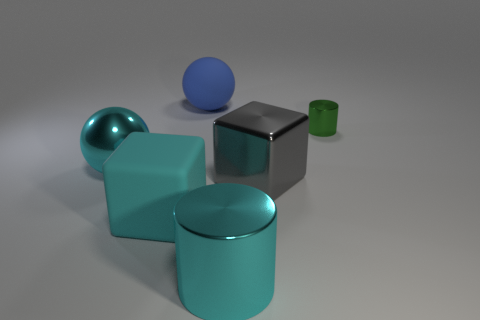Add 4 green cylinders. How many objects exist? 10 Subtract all blocks. How many objects are left? 4 Subtract all big shiny spheres. Subtract all cylinders. How many objects are left? 3 Add 3 metallic cylinders. How many metallic cylinders are left? 5 Add 4 tiny green objects. How many tiny green objects exist? 5 Subtract 1 cyan spheres. How many objects are left? 5 